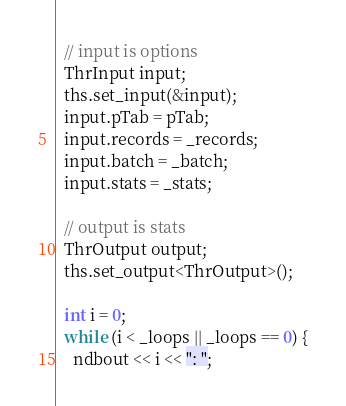<code> <loc_0><loc_0><loc_500><loc_500><_C++_>  // input is options
  ThrInput input;
  ths.set_input(&input);
  input.pTab = pTab;
  input.records = _records;
  input.batch = _batch;
  input.stats = _stats;

  // output is stats
  ThrOutput output;
  ths.set_output<ThrOutput>();

  int i = 0;
  while (i < _loops || _loops == 0) {
    ndbout << i << ": ";
</code> 